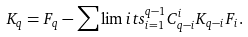Convert formula to latex. <formula><loc_0><loc_0><loc_500><loc_500>K _ { q } = F _ { q } - \sum \lim i t s _ { i = 1 } ^ { q - 1 } C _ { q - i } ^ { i } K _ { q - i } F _ { i } .</formula> 